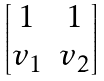<formula> <loc_0><loc_0><loc_500><loc_500>\begin{bmatrix} 1 & 1 \\ v _ { 1 } & v _ { 2 } \end{bmatrix}</formula> 